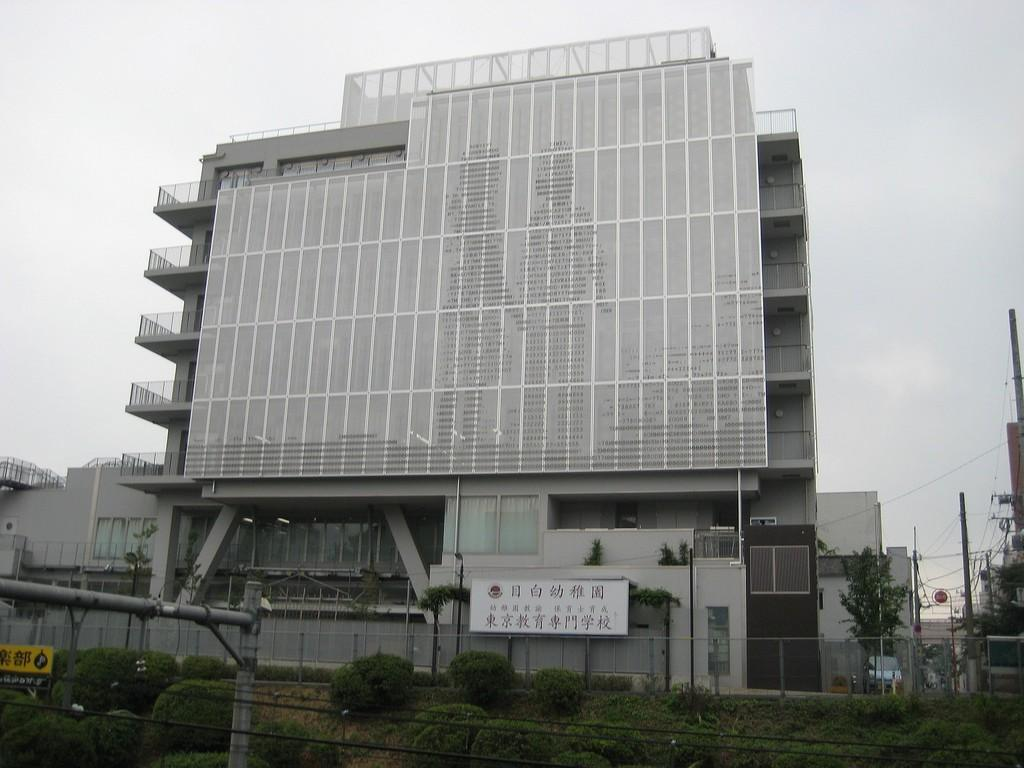What type of structures can be seen in the image? There are buildings in the image. What are the vertical structures with signs on them? Name boards are in the image. What type of poles are present in the image? Street poles and electric poles are visible in the image. What is connected to the electric poles? Electric cables are in the image. What type of vegetation can be seen in the image? Trees and bushes are present in the image. What else is visible in the image? Pipelines are in the image. What part of the natural environment is visible in the image? The sky is visible in the image. Where is the jail located in the image? There is no jail present in the image. What type of cart is being used to transport the lip in the image? There is no cart or lip present in the image. 